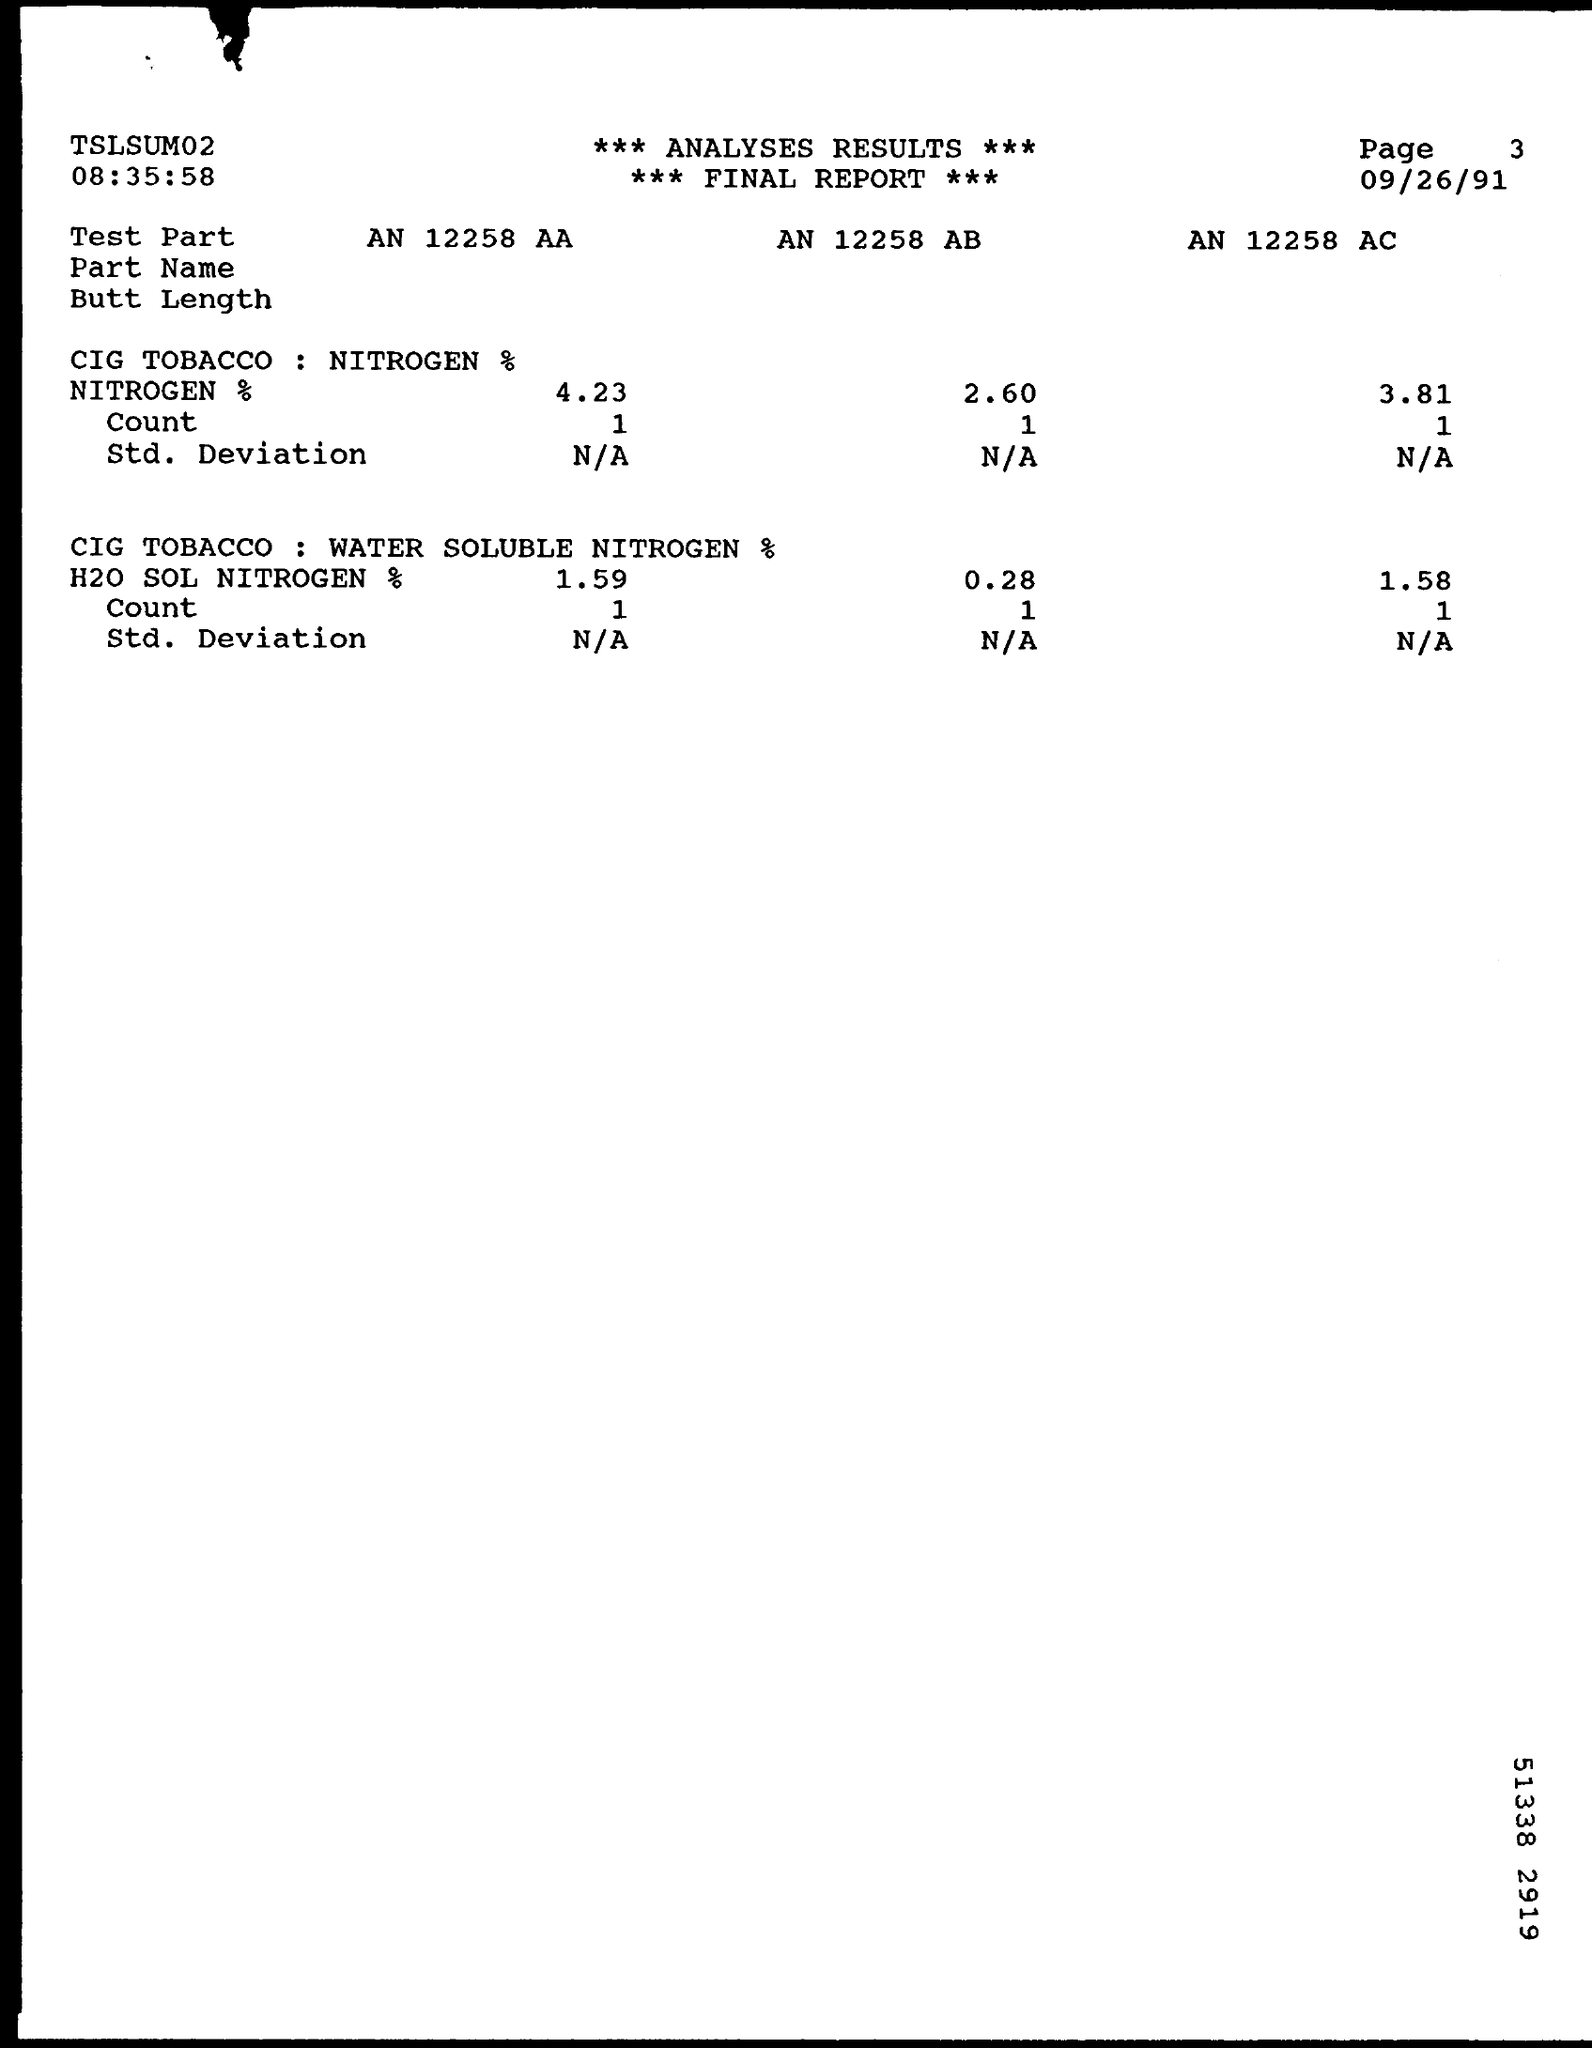What is the date mentioned in the final report ?
Offer a very short reply. 09/26/91. What is the value of count in test part an 12258 aa containing nitrogen ?
Keep it short and to the point. 1. 